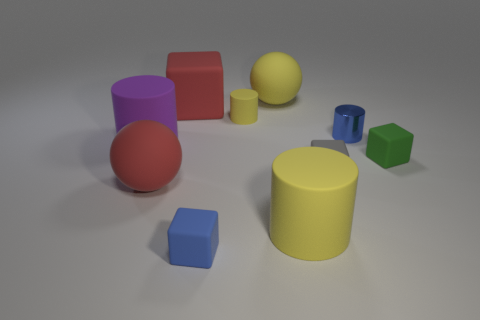Subtract all yellow cylinders. How many were subtracted if there are1yellow cylinders left? 1 Subtract all shiny cylinders. How many cylinders are left? 3 Subtract all red balls. How many balls are left? 1 Subtract all cubes. How many objects are left? 6 Subtract 4 blocks. How many blocks are left? 0 Add 2 large red cubes. How many large red cubes are left? 3 Add 10 tiny purple blocks. How many tiny purple blocks exist? 10 Subtract 0 green spheres. How many objects are left? 10 Subtract all brown cubes. Subtract all yellow spheres. How many cubes are left? 4 Subtract all brown balls. How many green cylinders are left? 0 